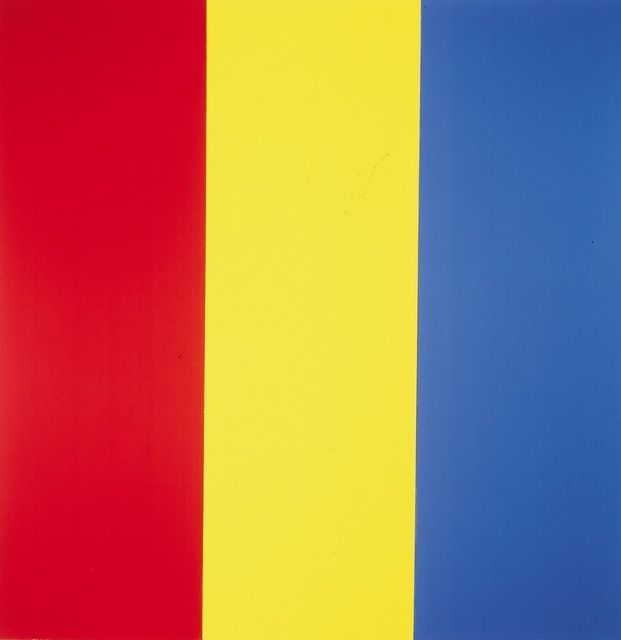What do you think is going on in this snapshot? The image is a remarkable example of minimalist art, specifically within the color field painting genre. It features three vertical stripes of equal width, each filled with a strong, unmodulated color. On the left is a vivid red stripe that captivates the viewer's attention with its intensity. The center boasts a bright yellow stripe, evoking a sense of warmth and joy reminiscent of a sunny day. On the right, a deep blue stripe adds depth and serenity, akin to the mysterious expanse of the night sky. The solo use of bold colors and the absence of extraneous details invite viewers to experience the pure essence of these colors, immersing themselves in the simplicity and power of the composition. 